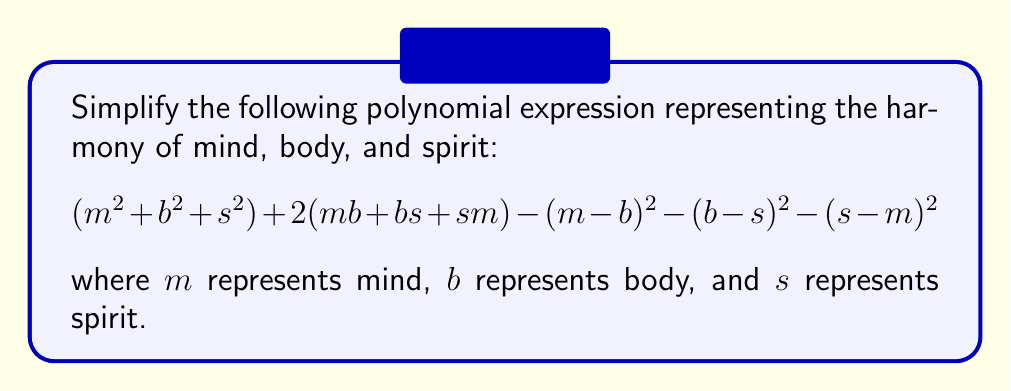Help me with this question. Let's approach this step-by-step:

1) First, let's expand the squared terms:
   $(m - b)^2 = m^2 - 2mb + b^2$
   $(b - s)^2 = b^2 - 2bs + s^2$
   $(s - m)^2 = s^2 - 2sm + m^2$

2) Now, let's substitute these back into the original expression:
   $$(m^2 + b^2 + s^2) + 2(mb + bs + sm) - (m^2 - 2mb + b^2) - (b^2 - 2bs + s^2) - (s^2 - 2sm + m^2)$$

3) Let's group like terms:
   $$(m^2 + b^2 + s^2) + 2mb + 2bs + 2sm - m^2 + 2mb - b^2 - b^2 + 2bs - s^2 - s^2 + 2sm - m^2$$

4) Simplify by cancelling out terms:
   $$2mb + 2bs + 2sm + 2mb + 2bs + 2sm$$

5) Combine like terms:
   $$4mb + 4bs + 4sm$$

6) Factor out the common factor:
   $$4(mb + bs + sm)$$

This final expression represents the harmony of mind, body, and spirit, as it shows the balanced interconnection between all three elements.
Answer: $$4(mb + bs + sm)$$ 